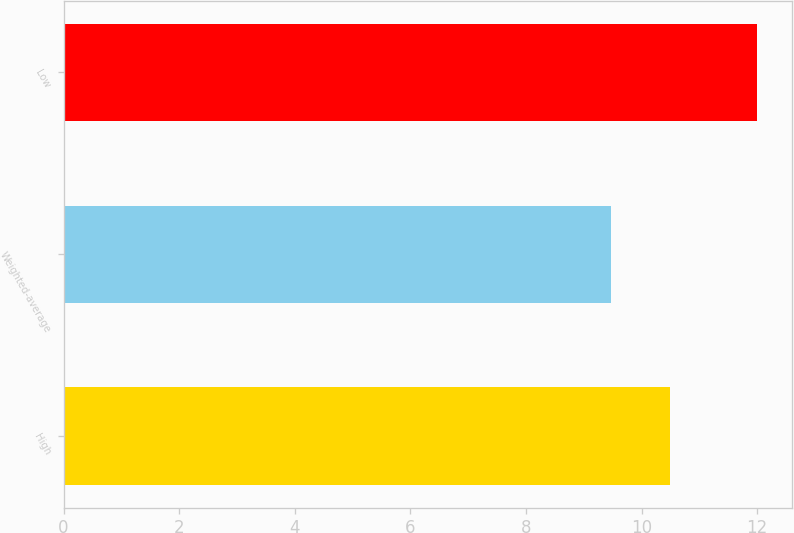Convert chart to OTSL. <chart><loc_0><loc_0><loc_500><loc_500><bar_chart><fcel>High<fcel>Weighted-average<fcel>Low<nl><fcel>10.5<fcel>9.47<fcel>12<nl></chart> 